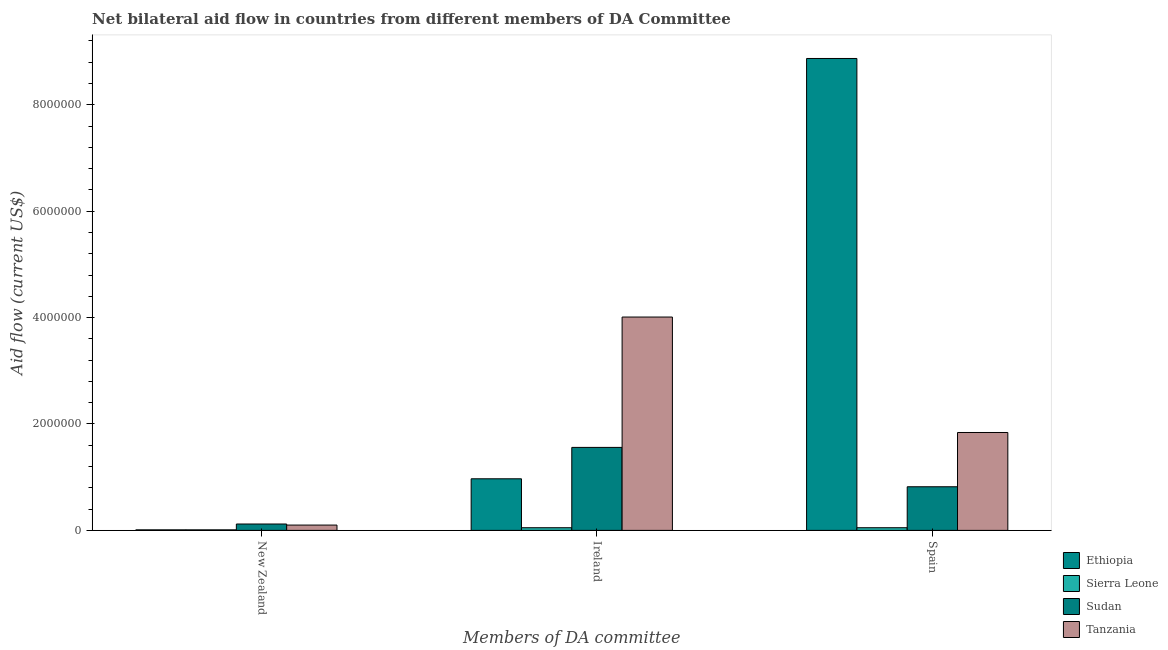How many different coloured bars are there?
Ensure brevity in your answer.  4. Are the number of bars per tick equal to the number of legend labels?
Provide a short and direct response. Yes. Are the number of bars on each tick of the X-axis equal?
Offer a very short reply. Yes. How many bars are there on the 1st tick from the left?
Offer a terse response. 4. How many bars are there on the 3rd tick from the right?
Provide a short and direct response. 4. What is the label of the 1st group of bars from the left?
Provide a short and direct response. New Zealand. What is the amount of aid provided by spain in Tanzania?
Your response must be concise. 1.84e+06. Across all countries, what is the maximum amount of aid provided by spain?
Your answer should be very brief. 8.87e+06. Across all countries, what is the minimum amount of aid provided by ireland?
Ensure brevity in your answer.  5.00e+04. In which country was the amount of aid provided by ireland maximum?
Offer a terse response. Tanzania. In which country was the amount of aid provided by new zealand minimum?
Ensure brevity in your answer.  Ethiopia. What is the total amount of aid provided by ireland in the graph?
Your answer should be very brief. 6.59e+06. What is the difference between the amount of aid provided by new zealand in Sudan and that in Ethiopia?
Provide a short and direct response. 1.10e+05. What is the difference between the amount of aid provided by spain in Tanzania and the amount of aid provided by ireland in Sudan?
Offer a terse response. 2.80e+05. What is the difference between the amount of aid provided by spain and amount of aid provided by new zealand in Tanzania?
Make the answer very short. 1.74e+06. In how many countries, is the amount of aid provided by spain greater than 6000000 US$?
Offer a very short reply. 1. What is the ratio of the amount of aid provided by new zealand in Tanzania to that in Ethiopia?
Provide a succinct answer. 10. What is the difference between the highest and the second highest amount of aid provided by ireland?
Keep it short and to the point. 2.45e+06. What is the difference between the highest and the lowest amount of aid provided by spain?
Make the answer very short. 8.82e+06. Is the sum of the amount of aid provided by new zealand in Ethiopia and Sierra Leone greater than the maximum amount of aid provided by ireland across all countries?
Keep it short and to the point. No. What does the 3rd bar from the left in New Zealand represents?
Your response must be concise. Sudan. What does the 3rd bar from the right in Spain represents?
Offer a very short reply. Sierra Leone. How many countries are there in the graph?
Make the answer very short. 4. What is the difference between two consecutive major ticks on the Y-axis?
Your answer should be compact. 2.00e+06. Are the values on the major ticks of Y-axis written in scientific E-notation?
Provide a succinct answer. No. Where does the legend appear in the graph?
Give a very brief answer. Bottom right. How are the legend labels stacked?
Offer a terse response. Vertical. What is the title of the graph?
Give a very brief answer. Net bilateral aid flow in countries from different members of DA Committee. Does "United States" appear as one of the legend labels in the graph?
Ensure brevity in your answer.  No. What is the label or title of the X-axis?
Your answer should be very brief. Members of DA committee. What is the Aid flow (current US$) in Ethiopia in New Zealand?
Keep it short and to the point. 10000. What is the Aid flow (current US$) of Sudan in New Zealand?
Offer a very short reply. 1.20e+05. What is the Aid flow (current US$) of Tanzania in New Zealand?
Offer a very short reply. 1.00e+05. What is the Aid flow (current US$) in Ethiopia in Ireland?
Offer a very short reply. 9.70e+05. What is the Aid flow (current US$) in Sierra Leone in Ireland?
Offer a very short reply. 5.00e+04. What is the Aid flow (current US$) in Sudan in Ireland?
Your answer should be very brief. 1.56e+06. What is the Aid flow (current US$) in Tanzania in Ireland?
Make the answer very short. 4.01e+06. What is the Aid flow (current US$) in Ethiopia in Spain?
Make the answer very short. 8.87e+06. What is the Aid flow (current US$) in Sudan in Spain?
Keep it short and to the point. 8.20e+05. What is the Aid flow (current US$) in Tanzania in Spain?
Offer a very short reply. 1.84e+06. Across all Members of DA committee, what is the maximum Aid flow (current US$) of Ethiopia?
Make the answer very short. 8.87e+06. Across all Members of DA committee, what is the maximum Aid flow (current US$) of Sudan?
Offer a terse response. 1.56e+06. Across all Members of DA committee, what is the maximum Aid flow (current US$) of Tanzania?
Give a very brief answer. 4.01e+06. Across all Members of DA committee, what is the minimum Aid flow (current US$) of Sudan?
Your response must be concise. 1.20e+05. What is the total Aid flow (current US$) in Ethiopia in the graph?
Keep it short and to the point. 9.85e+06. What is the total Aid flow (current US$) of Sierra Leone in the graph?
Your answer should be very brief. 1.10e+05. What is the total Aid flow (current US$) in Sudan in the graph?
Your answer should be very brief. 2.50e+06. What is the total Aid flow (current US$) in Tanzania in the graph?
Offer a very short reply. 5.95e+06. What is the difference between the Aid flow (current US$) in Ethiopia in New Zealand and that in Ireland?
Ensure brevity in your answer.  -9.60e+05. What is the difference between the Aid flow (current US$) of Sudan in New Zealand and that in Ireland?
Your answer should be compact. -1.44e+06. What is the difference between the Aid flow (current US$) in Tanzania in New Zealand and that in Ireland?
Your answer should be compact. -3.91e+06. What is the difference between the Aid flow (current US$) in Ethiopia in New Zealand and that in Spain?
Give a very brief answer. -8.86e+06. What is the difference between the Aid flow (current US$) of Sierra Leone in New Zealand and that in Spain?
Provide a short and direct response. -4.00e+04. What is the difference between the Aid flow (current US$) of Sudan in New Zealand and that in Spain?
Your answer should be compact. -7.00e+05. What is the difference between the Aid flow (current US$) of Tanzania in New Zealand and that in Spain?
Offer a very short reply. -1.74e+06. What is the difference between the Aid flow (current US$) of Ethiopia in Ireland and that in Spain?
Ensure brevity in your answer.  -7.90e+06. What is the difference between the Aid flow (current US$) in Sierra Leone in Ireland and that in Spain?
Offer a very short reply. 0. What is the difference between the Aid flow (current US$) in Sudan in Ireland and that in Spain?
Offer a very short reply. 7.40e+05. What is the difference between the Aid flow (current US$) in Tanzania in Ireland and that in Spain?
Your answer should be compact. 2.17e+06. What is the difference between the Aid flow (current US$) in Ethiopia in New Zealand and the Aid flow (current US$) in Sierra Leone in Ireland?
Offer a very short reply. -4.00e+04. What is the difference between the Aid flow (current US$) in Ethiopia in New Zealand and the Aid flow (current US$) in Sudan in Ireland?
Provide a succinct answer. -1.55e+06. What is the difference between the Aid flow (current US$) of Ethiopia in New Zealand and the Aid flow (current US$) of Tanzania in Ireland?
Make the answer very short. -4.00e+06. What is the difference between the Aid flow (current US$) in Sierra Leone in New Zealand and the Aid flow (current US$) in Sudan in Ireland?
Offer a very short reply. -1.55e+06. What is the difference between the Aid flow (current US$) in Sudan in New Zealand and the Aid flow (current US$) in Tanzania in Ireland?
Offer a terse response. -3.89e+06. What is the difference between the Aid flow (current US$) of Ethiopia in New Zealand and the Aid flow (current US$) of Sierra Leone in Spain?
Your answer should be compact. -4.00e+04. What is the difference between the Aid flow (current US$) of Ethiopia in New Zealand and the Aid flow (current US$) of Sudan in Spain?
Offer a terse response. -8.10e+05. What is the difference between the Aid flow (current US$) of Ethiopia in New Zealand and the Aid flow (current US$) of Tanzania in Spain?
Ensure brevity in your answer.  -1.83e+06. What is the difference between the Aid flow (current US$) of Sierra Leone in New Zealand and the Aid flow (current US$) of Sudan in Spain?
Provide a succinct answer. -8.10e+05. What is the difference between the Aid flow (current US$) in Sierra Leone in New Zealand and the Aid flow (current US$) in Tanzania in Spain?
Provide a short and direct response. -1.83e+06. What is the difference between the Aid flow (current US$) of Sudan in New Zealand and the Aid flow (current US$) of Tanzania in Spain?
Your response must be concise. -1.72e+06. What is the difference between the Aid flow (current US$) in Ethiopia in Ireland and the Aid flow (current US$) in Sierra Leone in Spain?
Your answer should be compact. 9.20e+05. What is the difference between the Aid flow (current US$) of Ethiopia in Ireland and the Aid flow (current US$) of Tanzania in Spain?
Provide a succinct answer. -8.70e+05. What is the difference between the Aid flow (current US$) in Sierra Leone in Ireland and the Aid flow (current US$) in Sudan in Spain?
Your answer should be compact. -7.70e+05. What is the difference between the Aid flow (current US$) in Sierra Leone in Ireland and the Aid flow (current US$) in Tanzania in Spain?
Ensure brevity in your answer.  -1.79e+06. What is the difference between the Aid flow (current US$) of Sudan in Ireland and the Aid flow (current US$) of Tanzania in Spain?
Your answer should be very brief. -2.80e+05. What is the average Aid flow (current US$) of Ethiopia per Members of DA committee?
Offer a terse response. 3.28e+06. What is the average Aid flow (current US$) of Sierra Leone per Members of DA committee?
Your response must be concise. 3.67e+04. What is the average Aid flow (current US$) of Sudan per Members of DA committee?
Provide a succinct answer. 8.33e+05. What is the average Aid flow (current US$) in Tanzania per Members of DA committee?
Give a very brief answer. 1.98e+06. What is the difference between the Aid flow (current US$) of Ethiopia and Aid flow (current US$) of Sierra Leone in New Zealand?
Give a very brief answer. 0. What is the difference between the Aid flow (current US$) of Sierra Leone and Aid flow (current US$) of Tanzania in New Zealand?
Offer a very short reply. -9.00e+04. What is the difference between the Aid flow (current US$) in Ethiopia and Aid flow (current US$) in Sierra Leone in Ireland?
Offer a terse response. 9.20e+05. What is the difference between the Aid flow (current US$) in Ethiopia and Aid flow (current US$) in Sudan in Ireland?
Your answer should be very brief. -5.90e+05. What is the difference between the Aid flow (current US$) of Ethiopia and Aid flow (current US$) of Tanzania in Ireland?
Your answer should be very brief. -3.04e+06. What is the difference between the Aid flow (current US$) in Sierra Leone and Aid flow (current US$) in Sudan in Ireland?
Give a very brief answer. -1.51e+06. What is the difference between the Aid flow (current US$) of Sierra Leone and Aid flow (current US$) of Tanzania in Ireland?
Provide a short and direct response. -3.96e+06. What is the difference between the Aid flow (current US$) of Sudan and Aid flow (current US$) of Tanzania in Ireland?
Your answer should be compact. -2.45e+06. What is the difference between the Aid flow (current US$) in Ethiopia and Aid flow (current US$) in Sierra Leone in Spain?
Make the answer very short. 8.82e+06. What is the difference between the Aid flow (current US$) in Ethiopia and Aid flow (current US$) in Sudan in Spain?
Provide a succinct answer. 8.05e+06. What is the difference between the Aid flow (current US$) in Ethiopia and Aid flow (current US$) in Tanzania in Spain?
Make the answer very short. 7.03e+06. What is the difference between the Aid flow (current US$) of Sierra Leone and Aid flow (current US$) of Sudan in Spain?
Ensure brevity in your answer.  -7.70e+05. What is the difference between the Aid flow (current US$) in Sierra Leone and Aid flow (current US$) in Tanzania in Spain?
Your response must be concise. -1.79e+06. What is the difference between the Aid flow (current US$) of Sudan and Aid flow (current US$) of Tanzania in Spain?
Provide a short and direct response. -1.02e+06. What is the ratio of the Aid flow (current US$) in Ethiopia in New Zealand to that in Ireland?
Your response must be concise. 0.01. What is the ratio of the Aid flow (current US$) in Sudan in New Zealand to that in Ireland?
Offer a very short reply. 0.08. What is the ratio of the Aid flow (current US$) in Tanzania in New Zealand to that in Ireland?
Provide a succinct answer. 0.02. What is the ratio of the Aid flow (current US$) of Ethiopia in New Zealand to that in Spain?
Offer a terse response. 0. What is the ratio of the Aid flow (current US$) in Sudan in New Zealand to that in Spain?
Make the answer very short. 0.15. What is the ratio of the Aid flow (current US$) of Tanzania in New Zealand to that in Spain?
Provide a short and direct response. 0.05. What is the ratio of the Aid flow (current US$) in Ethiopia in Ireland to that in Spain?
Your response must be concise. 0.11. What is the ratio of the Aid flow (current US$) in Sudan in Ireland to that in Spain?
Offer a terse response. 1.9. What is the ratio of the Aid flow (current US$) of Tanzania in Ireland to that in Spain?
Your answer should be very brief. 2.18. What is the difference between the highest and the second highest Aid flow (current US$) of Ethiopia?
Your answer should be compact. 7.90e+06. What is the difference between the highest and the second highest Aid flow (current US$) in Sierra Leone?
Ensure brevity in your answer.  0. What is the difference between the highest and the second highest Aid flow (current US$) in Sudan?
Give a very brief answer. 7.40e+05. What is the difference between the highest and the second highest Aid flow (current US$) of Tanzania?
Ensure brevity in your answer.  2.17e+06. What is the difference between the highest and the lowest Aid flow (current US$) of Ethiopia?
Ensure brevity in your answer.  8.86e+06. What is the difference between the highest and the lowest Aid flow (current US$) in Sudan?
Your answer should be compact. 1.44e+06. What is the difference between the highest and the lowest Aid flow (current US$) in Tanzania?
Offer a terse response. 3.91e+06. 